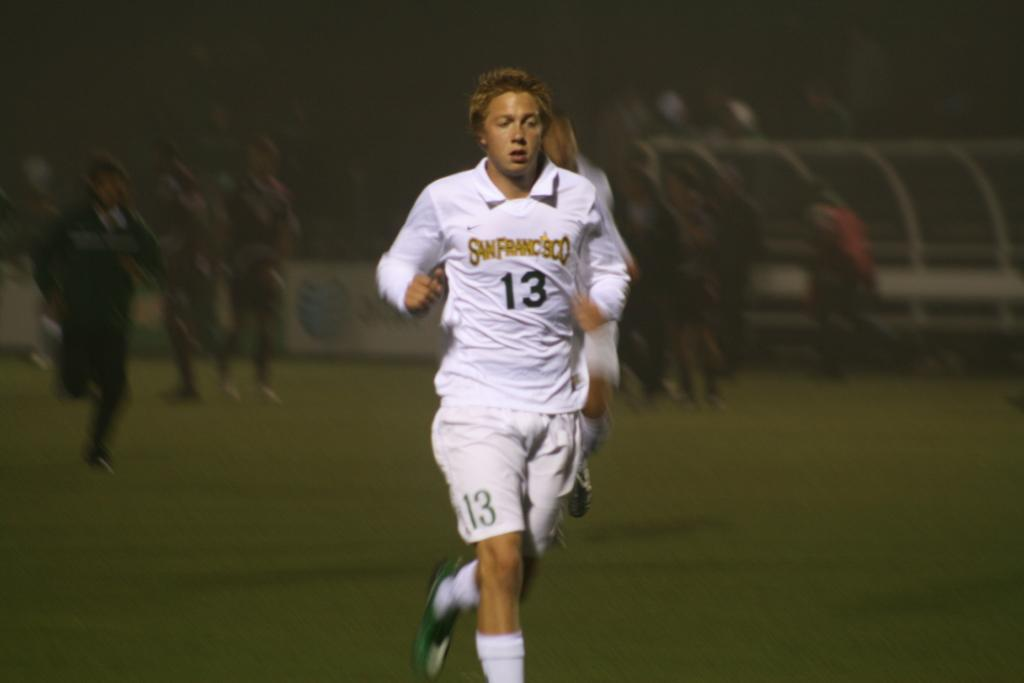<image>
Render a clear and concise summary of the photo. a player with the number 13 on their jersey 